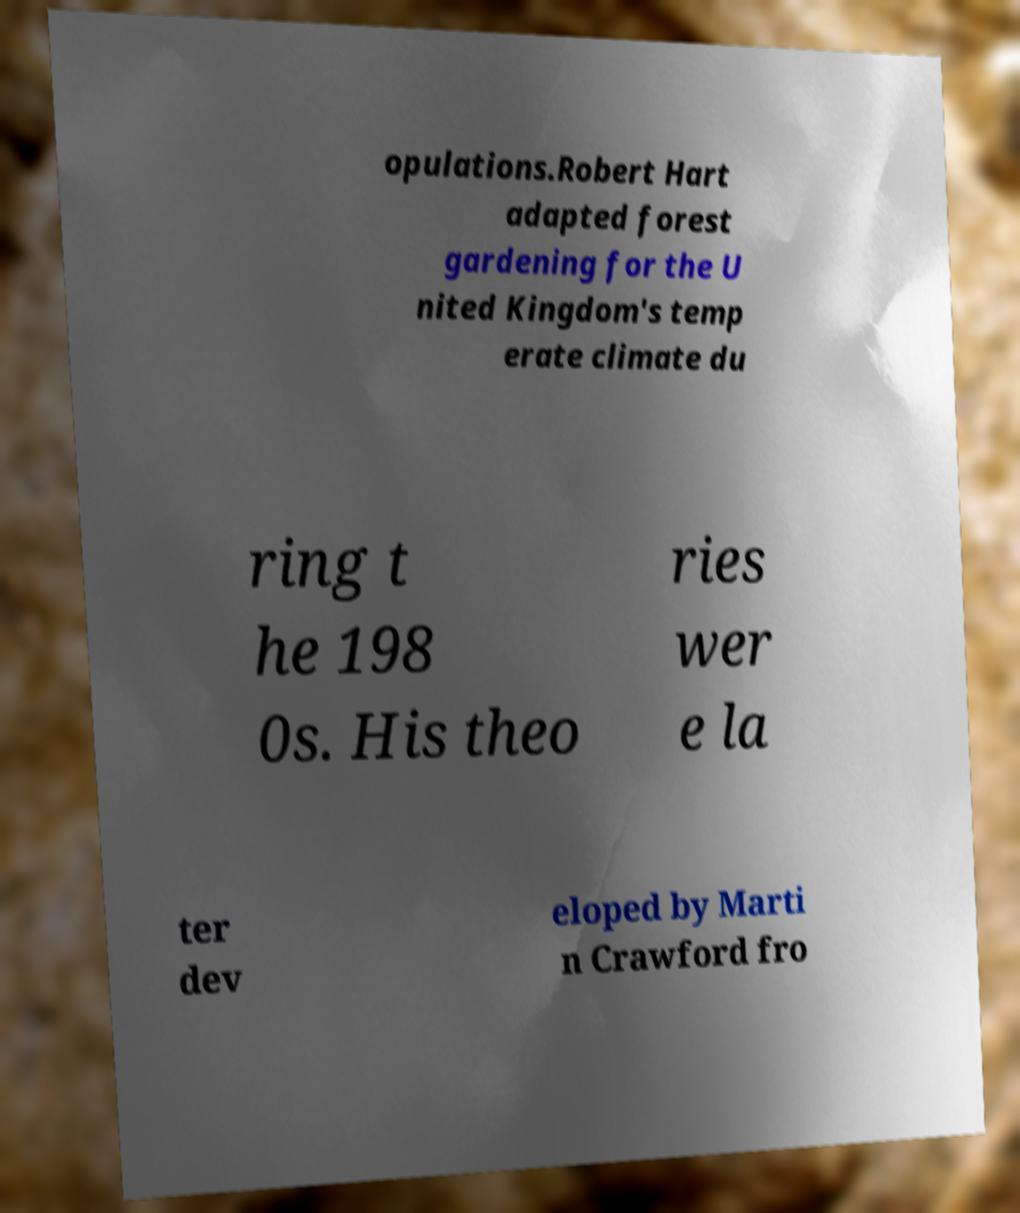Could you extract and type out the text from this image? opulations.Robert Hart adapted forest gardening for the U nited Kingdom's temp erate climate du ring t he 198 0s. His theo ries wer e la ter dev eloped by Marti n Crawford fro 